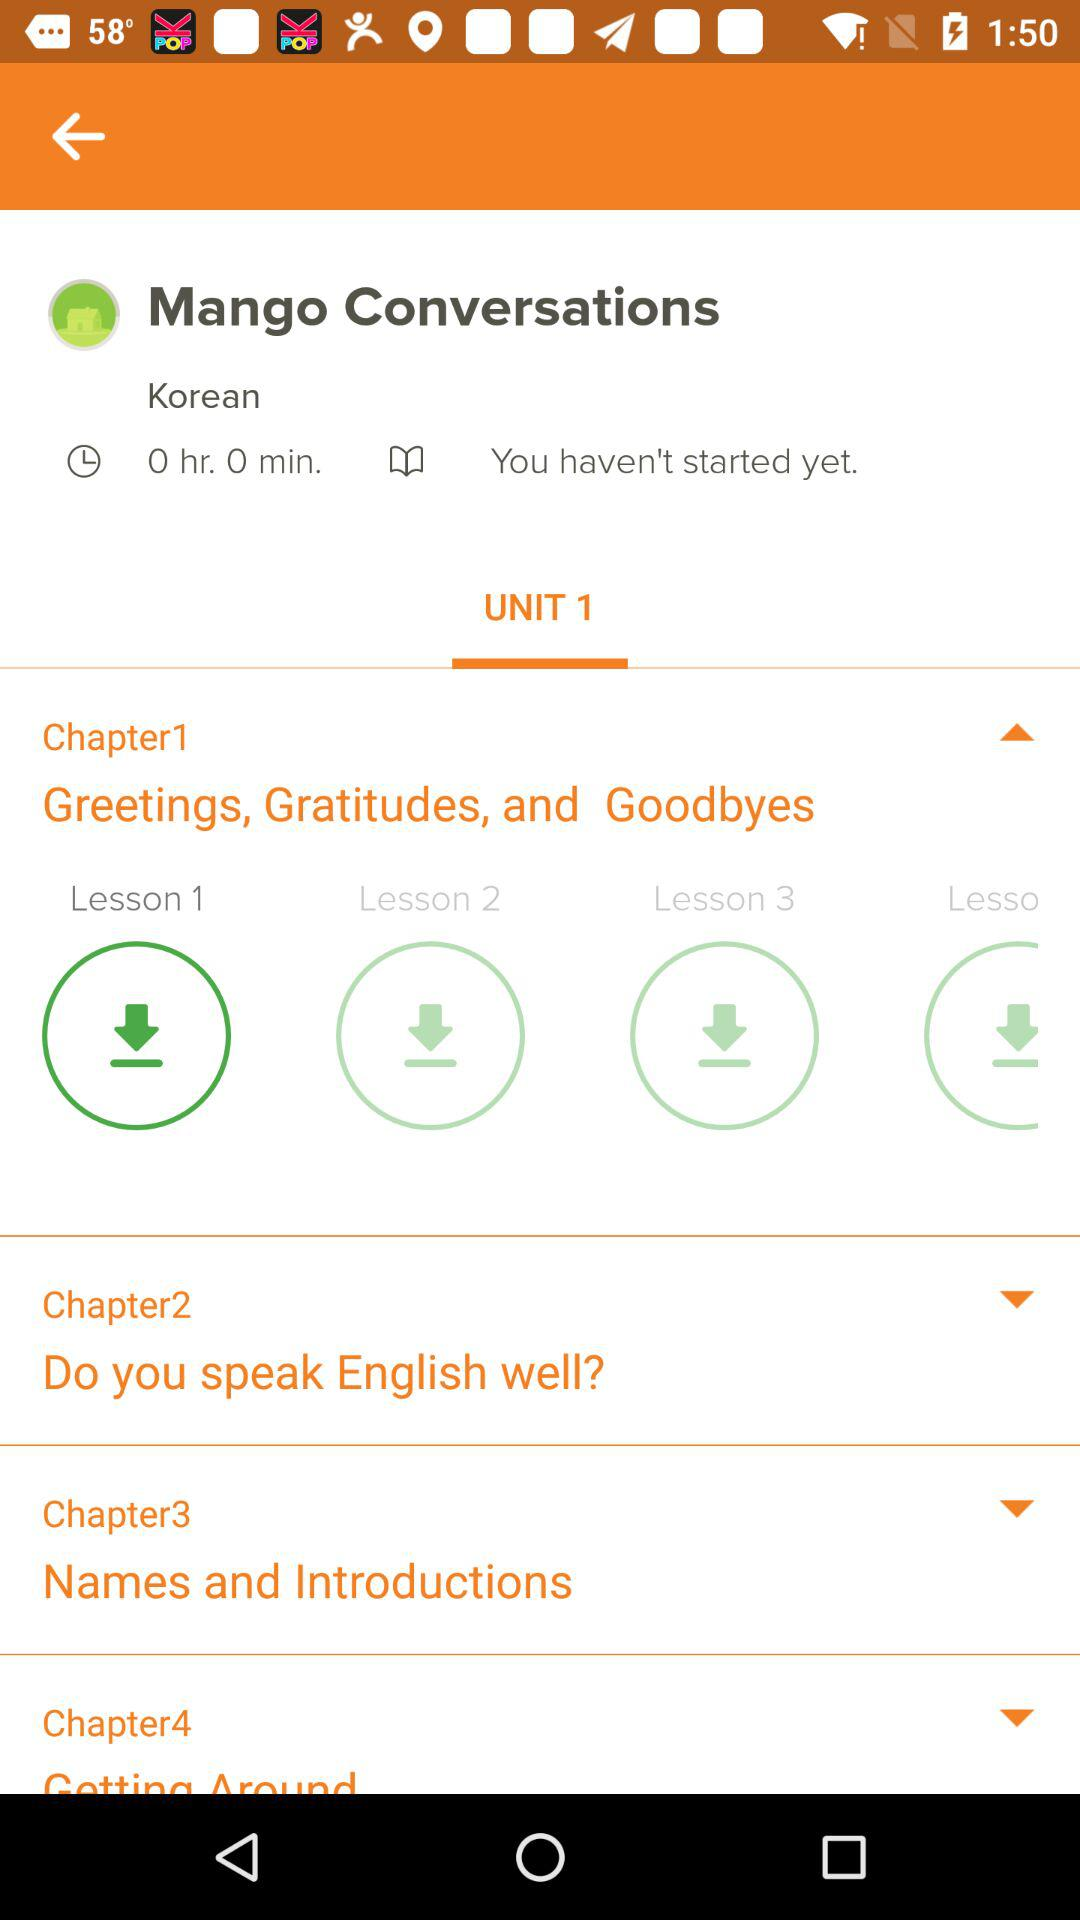Can you tell me more about what I might learn in Chapter 1? Chapter 1, titled 'Greetings, Gratitudes, and Goodbyes', is designed to introduce you to common expressions in social interactions. You can expect to learn how to say hello, thank someone, and say goodbye in various formal and informal contexts. 